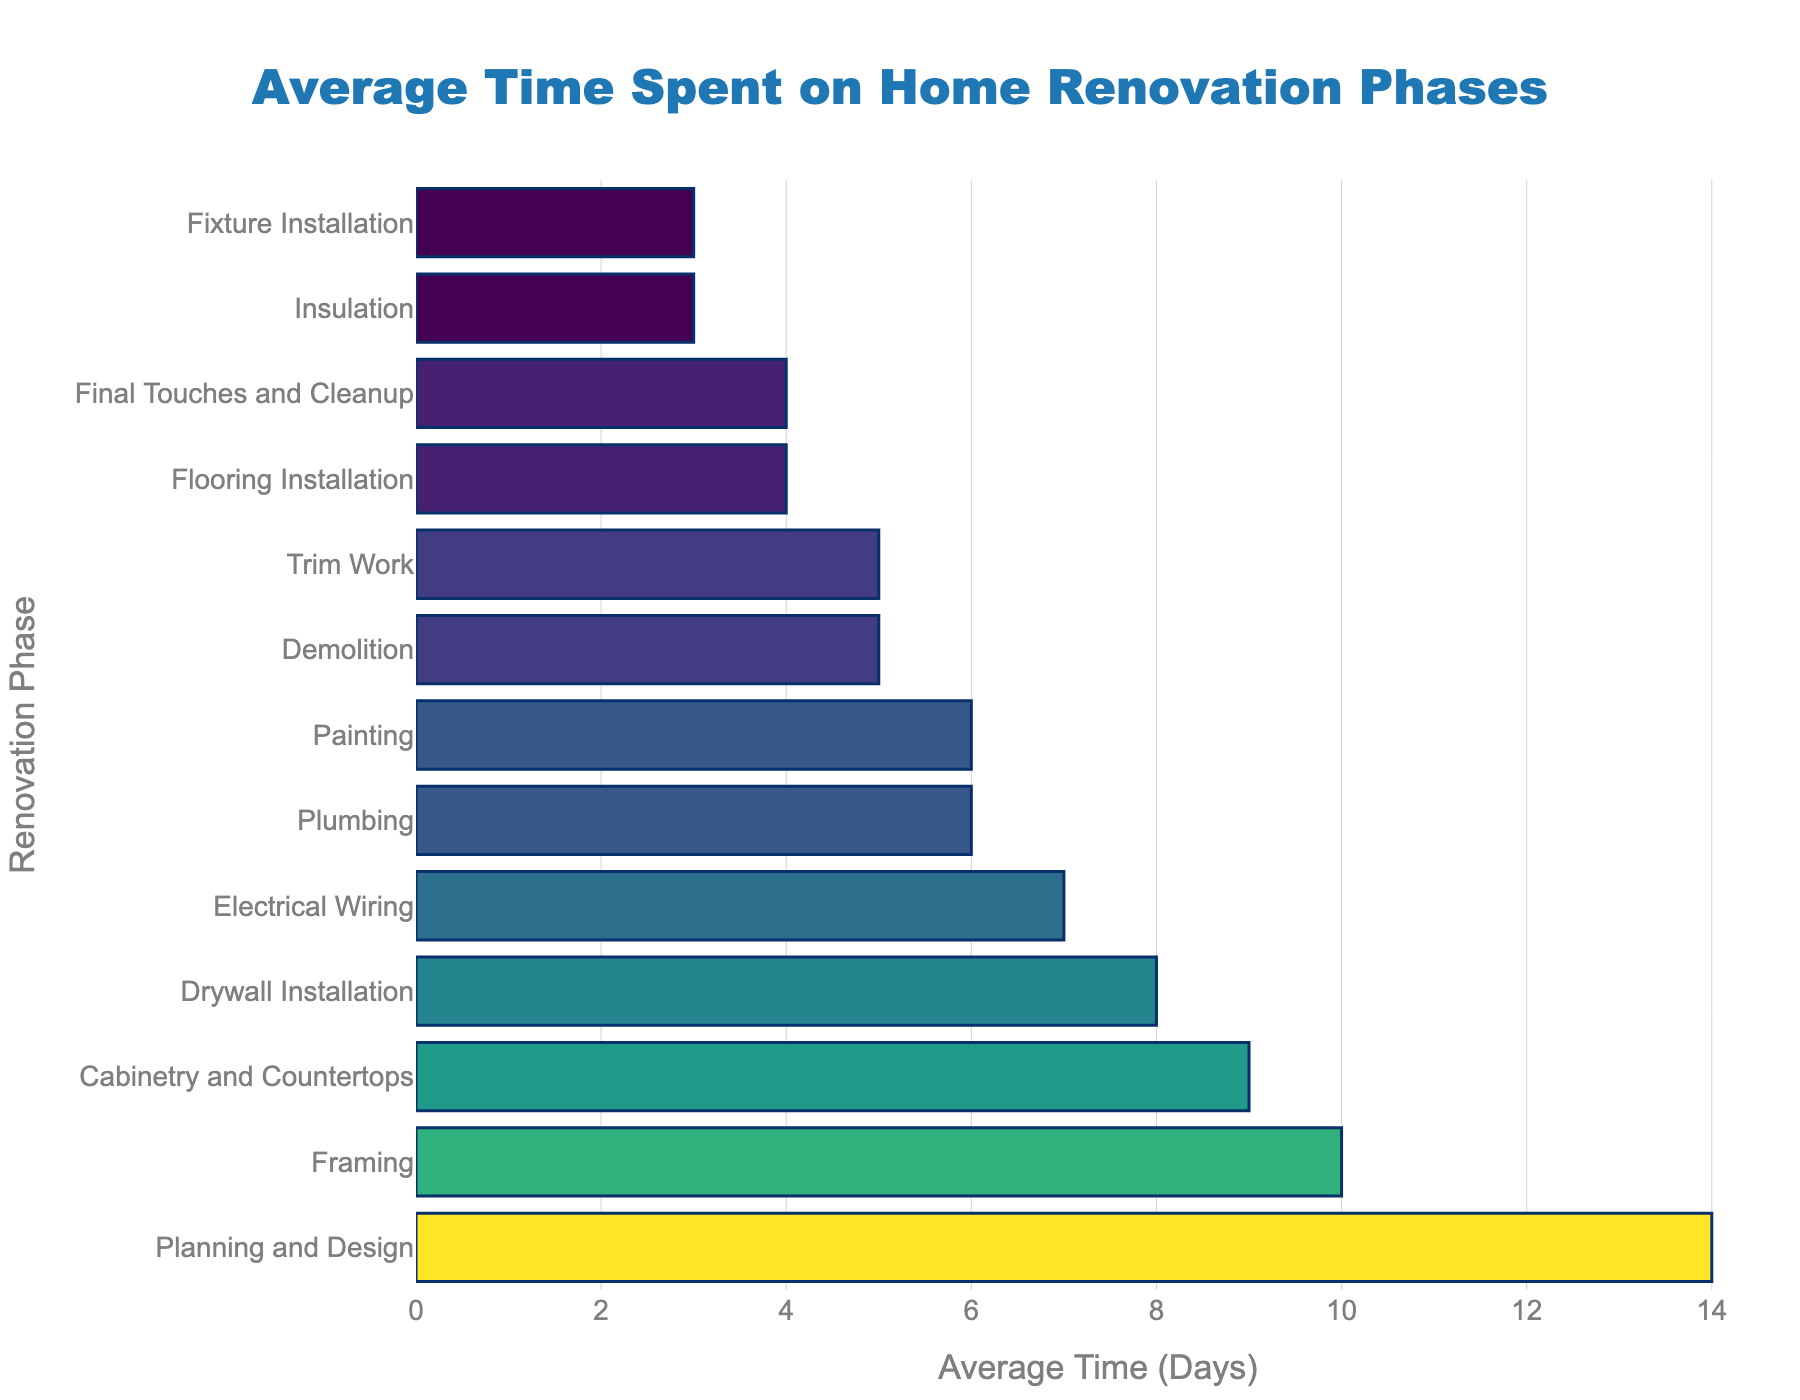Which phase takes the longest time? The phase with the highest bar length represents the longest time. In this case, it is "Planning and Design" with an average time of 14 days.
Answer: Planning and Design Which phase takes the shortest time? The phase with the shortest bar length represents the shortest time. In this case, it is "Insulation" and "Fixture Installation" with an average time of 3 days each.
Answer: Insulation and Fixture Installation How much more time does Planning and Design take compared to Demolition? Planning and Design takes 14 days, and Demolition takes 5 days. The difference is 14 - 5 = 9 days.
Answer: 9 days What is the combined time for Electrical Wiring and Plumbing? Electrical Wiring takes 7 days and Plumbing takes 6 days. The combined time is 7 + 6 = 13 days.
Answer: 13 days Which phase takes more time, Drywall Installation or Trim Work? Drywall Installation takes 8 days, while Trim Work takes 5 days. Therefore, Drywall Installation takes more time.
Answer: Drywall Installation What is the average time spent on Painting, Flooring Installation, and Final Touches and Cleanup combined? Time for Painting is 6 days, Flooring Installation is 4 days, and Final Touches and Cleanup is 4 days. Sum is 6 + 4 + 4 = 14 days. Average is 14 / 3 = 4.67 days.
Answer: 4.67 days Which phase falls between 5 and 10 days and involves structural work? Structural work typically includes Framing, which takes 10 days and falls between 5 and 10 days.
Answer: Framing How much time is spent in total on phases that involve detailed finishing work (Painting, Trim Work, and Fixture Installation)? Painting takes 6 days, Trim Work takes 5 days, and Fixture Installation takes 3 days. Total time is 6 + 5 + 3 = 14 days.
Answer: 14 days Which two phases have exactly the same time allocation and what is that time? Demolition and Trim Work both take 5 days.
Answer: Demolition and Trim Work, 5 days What is the median time spent across all phases? Sorting the values: 3, 3, 4, 4, 5, 5, 6, 6, 7, 8, 9, 10, 14. The median value (middle value) is 6 days.
Answer: 6 days 